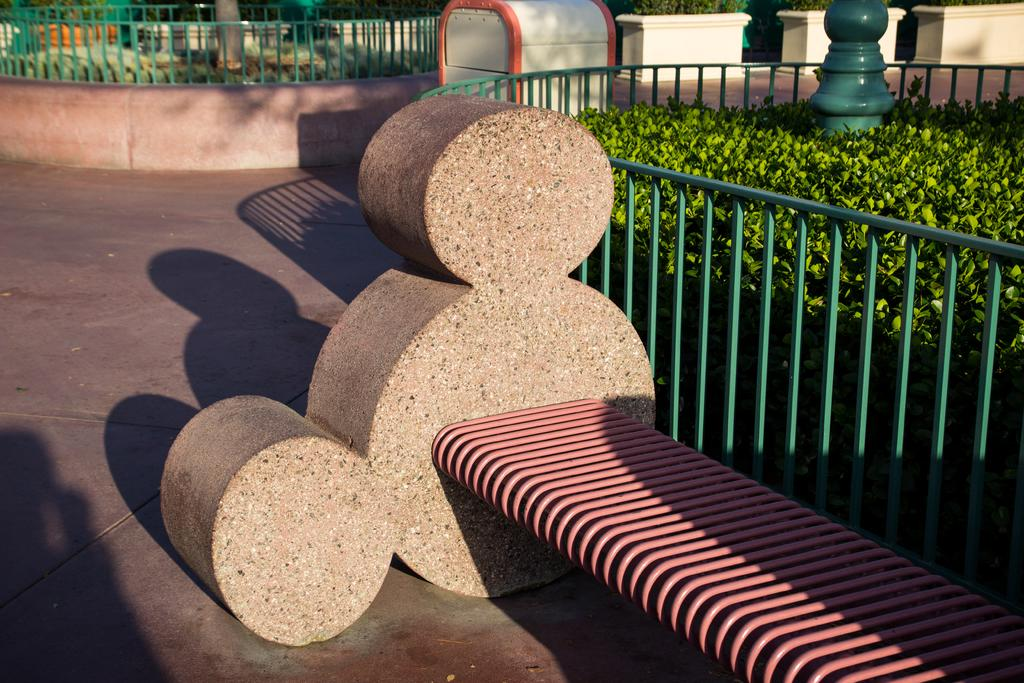What type of living organisms can be seen in the image? Plants can be seen in the image. What type of structure is present in the image? There is fencing in the image. What are the tall, thin structures in the image? There are poles in the image. What can be found in the image besides plants and fencing? There are objects and a bench in the image. What word is written on the bench in the image? There is no word written on the bench in the image. How many people are sitting on the bench in the image? There is no person present in the image, only a bench. 